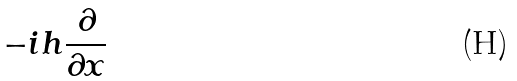Convert formula to latex. <formula><loc_0><loc_0><loc_500><loc_500>- i h \frac { \partial } { \partial x }</formula> 